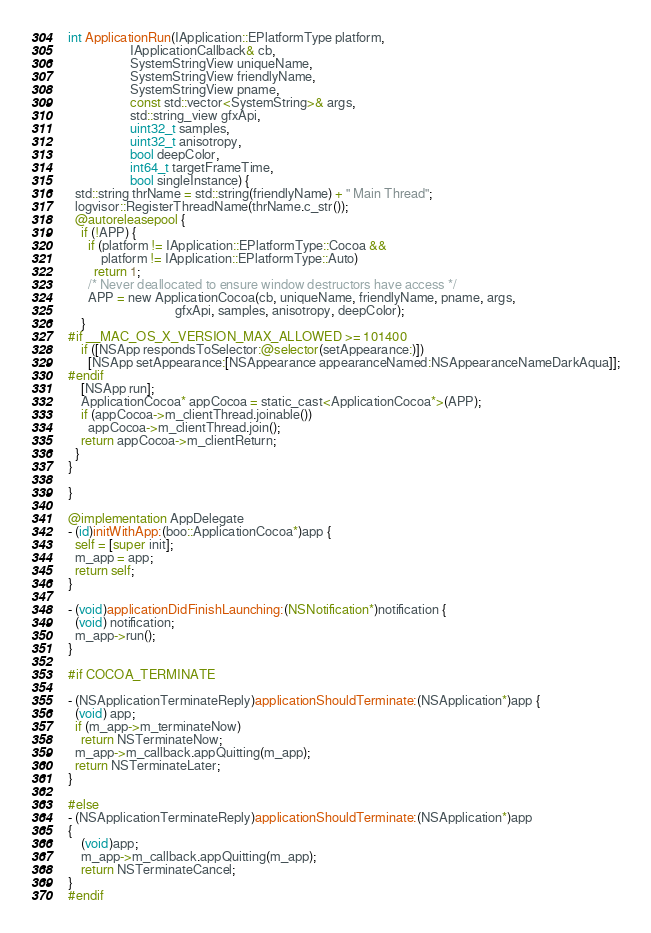Convert code to text. <code><loc_0><loc_0><loc_500><loc_500><_ObjectiveC_>
int ApplicationRun(IApplication::EPlatformType platform,
                   IApplicationCallback& cb,
                   SystemStringView uniqueName,
                   SystemStringView friendlyName,
                   SystemStringView pname,
                   const std::vector<SystemString>& args,
                   std::string_view gfxApi,
                   uint32_t samples,
                   uint32_t anisotropy,
                   bool deepColor,
                   int64_t targetFrameTime,
                   bool singleInstance) {
  std::string thrName = std::string(friendlyName) + " Main Thread";
  logvisor::RegisterThreadName(thrName.c_str());
  @autoreleasepool {
    if (!APP) {
      if (platform != IApplication::EPlatformType::Cocoa &&
          platform != IApplication::EPlatformType::Auto)
        return 1;
      /* Never deallocated to ensure window destructors have access */
      APP = new ApplicationCocoa(cb, uniqueName, friendlyName, pname, args,
                                 gfxApi, samples, anisotropy, deepColor);
    }
#if __MAC_OS_X_VERSION_MAX_ALLOWED >= 101400
    if ([NSApp respondsToSelector:@selector(setAppearance:)])
      [NSApp setAppearance:[NSAppearance appearanceNamed:NSAppearanceNameDarkAqua]];
#endif
    [NSApp run];
    ApplicationCocoa* appCocoa = static_cast<ApplicationCocoa*>(APP);
    if (appCocoa->m_clientThread.joinable())
      appCocoa->m_clientThread.join();
    return appCocoa->m_clientReturn;
  }
}

}

@implementation AppDelegate
- (id)initWithApp:(boo::ApplicationCocoa*)app {
  self = [super init];
  m_app = app;
  return self;
}

- (void)applicationDidFinishLaunching:(NSNotification*)notification {
  (void) notification;
  m_app->run();
}

#if COCOA_TERMINATE

- (NSApplicationTerminateReply)applicationShouldTerminate:(NSApplication*)app {
  (void) app;
  if (m_app->m_terminateNow)
    return NSTerminateNow;
  m_app->m_callback.appQuitting(m_app);
  return NSTerminateLater;
}

#else
- (NSApplicationTerminateReply)applicationShouldTerminate:(NSApplication*)app
{
    (void)app;
    m_app->m_callback.appQuitting(m_app);
    return NSTerminateCancel;
}
#endif
</code> 